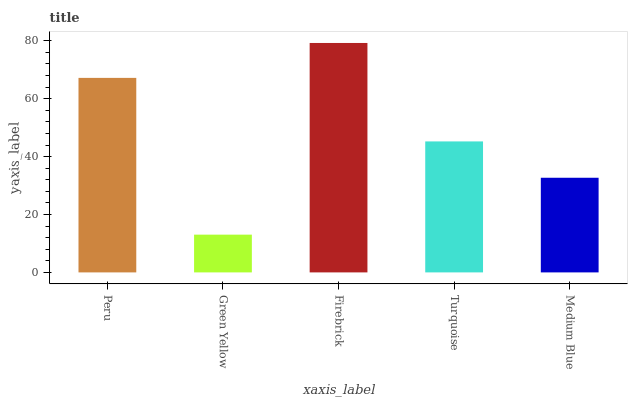Is Green Yellow the minimum?
Answer yes or no. Yes. Is Firebrick the maximum?
Answer yes or no. Yes. Is Firebrick the minimum?
Answer yes or no. No. Is Green Yellow the maximum?
Answer yes or no. No. Is Firebrick greater than Green Yellow?
Answer yes or no. Yes. Is Green Yellow less than Firebrick?
Answer yes or no. Yes. Is Green Yellow greater than Firebrick?
Answer yes or no. No. Is Firebrick less than Green Yellow?
Answer yes or no. No. Is Turquoise the high median?
Answer yes or no. Yes. Is Turquoise the low median?
Answer yes or no. Yes. Is Medium Blue the high median?
Answer yes or no. No. Is Medium Blue the low median?
Answer yes or no. No. 